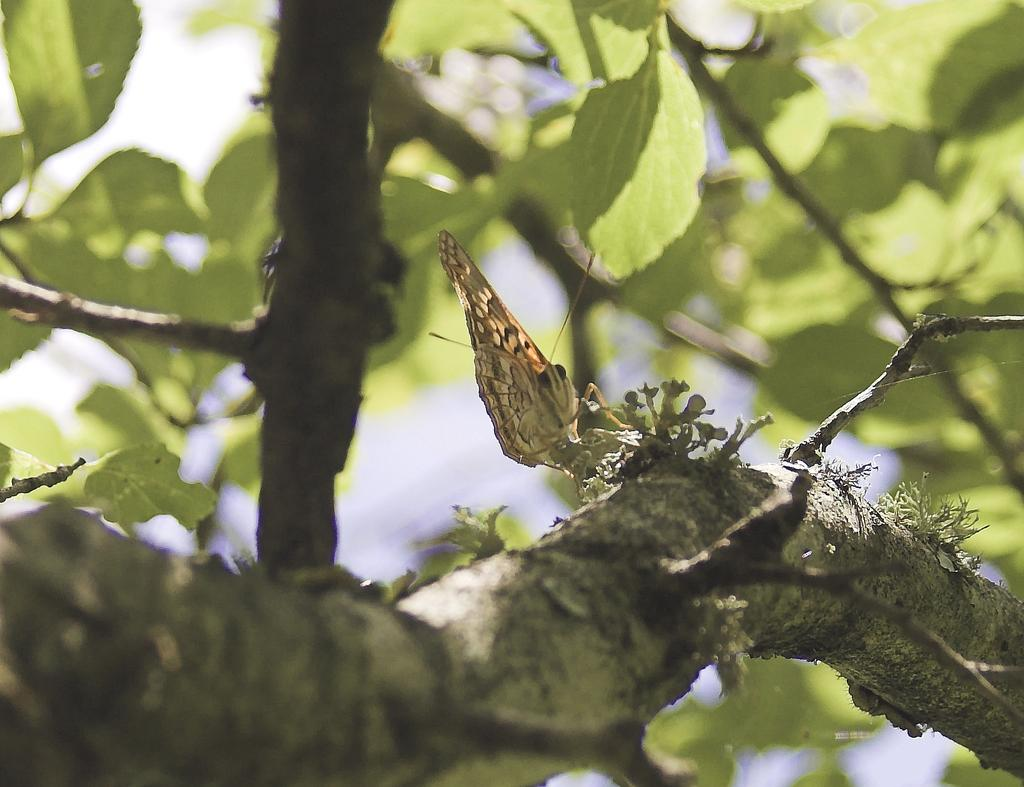What type of plant is visible in the image? There are branches and green leaves of a tree in the image. What else can be seen in the image besides the tree? There is an insect in the center of the image. How would you describe the overall clarity of the image? The image is slightly blurry in the background. What type of tank is visible in the image? There is no tank present in the image; it features a tree with branches and green leaves, as well as an insect. How does the insect interact with the garden in the image? There is no garden present in the image; it only features a tree and an insect. 